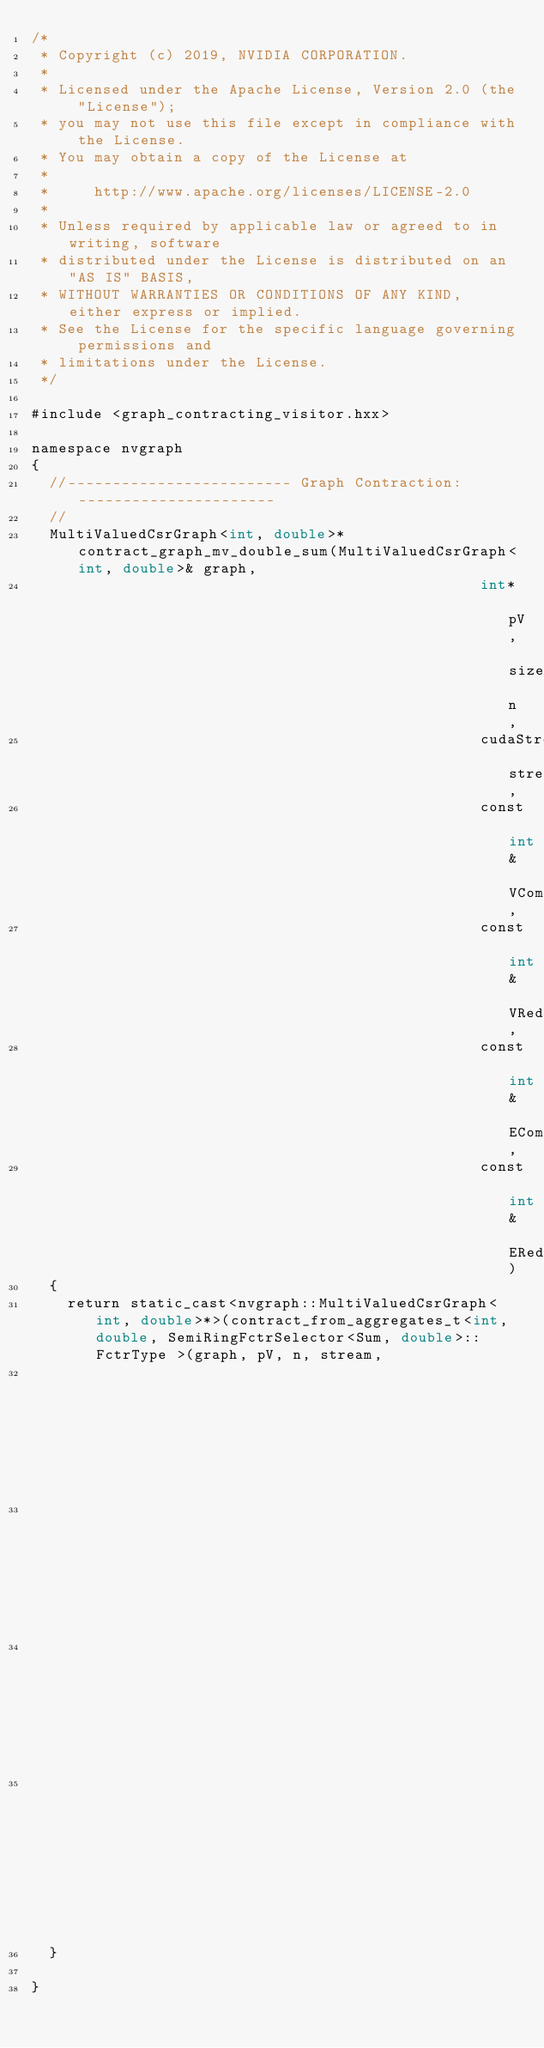Convert code to text. <code><loc_0><loc_0><loc_500><loc_500><_Cuda_>/*
 * Copyright (c) 2019, NVIDIA CORPORATION.
 *
 * Licensed under the Apache License, Version 2.0 (the "License");
 * you may not use this file except in compliance with the License.
 * You may obtain a copy of the License at
 *
 *     http://www.apache.org/licenses/LICENSE-2.0
 *
 * Unless required by applicable law or agreed to in writing, software
 * distributed under the License is distributed on an "AS IS" BASIS,
 * WITHOUT WARRANTIES OR CONDITIONS OF ANY KIND, either express or implied.
 * See the License for the specific language governing permissions and
 * limitations under the License.
 */

#include <graph_contracting_visitor.hxx>

namespace nvgraph
{
  //------------------------- Graph Contraction: ----------------------
  //
  MultiValuedCsrGraph<int, double>* contract_graph_mv_double_sum(MultiValuedCsrGraph<int, double>& graph, 
                                                  int* pV, size_t n,
                                                  cudaStream_t stream,
                                                  const int& VCombine,
                                                  const int& VReduce,
                                                  const int& ECombine,
                                                  const int& EReduce)
  {
    return static_cast<nvgraph::MultiValuedCsrGraph<int, double>*>(contract_from_aggregates_t<int, double, SemiRingFctrSelector<Sum, double>::FctrType >(graph, pV, n, stream,
                                                                                                       static_cast<SemiRingFunctorTypes>(VCombine),
                                                                                                       static_cast<SemiRingFunctorTypes>(VReduce),
                                                                                                       static_cast<SemiRingFunctorTypes>(ECombine),
                                                                                                       static_cast<SemiRingFunctorTypes>(EReduce)));
  }
 
}
</code> 